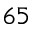Convert formula to latex. <formula><loc_0><loc_0><loc_500><loc_500>6 5</formula> 